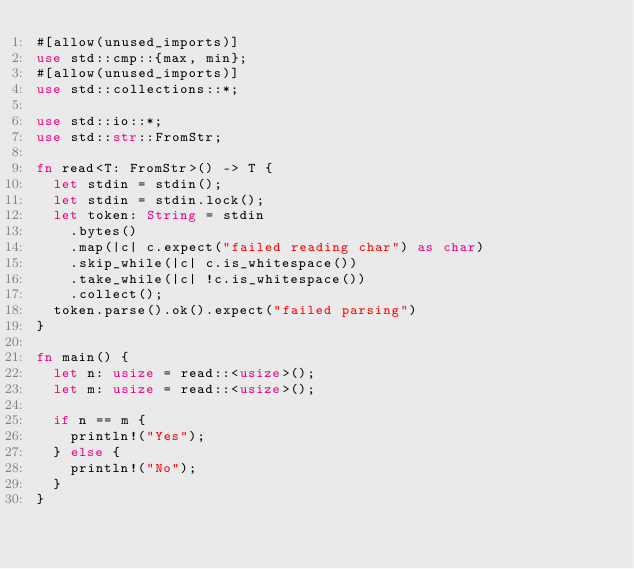<code> <loc_0><loc_0><loc_500><loc_500><_Rust_>#[allow(unused_imports)]
use std::cmp::{max, min};
#[allow(unused_imports)]
use std::collections::*;

use std::io::*;
use std::str::FromStr;

fn read<T: FromStr>() -> T {
  let stdin = stdin();
  let stdin = stdin.lock();
  let token: String = stdin
    .bytes()
    .map(|c| c.expect("failed reading char") as char)
    .skip_while(|c| c.is_whitespace())
    .take_while(|c| !c.is_whitespace())
    .collect();
  token.parse().ok().expect("failed parsing")
}

fn main() {
  let n: usize = read::<usize>();
  let m: usize = read::<usize>();

  if n == m {
    println!("Yes");
  } else {
    println!("No");
  }
}
</code> 